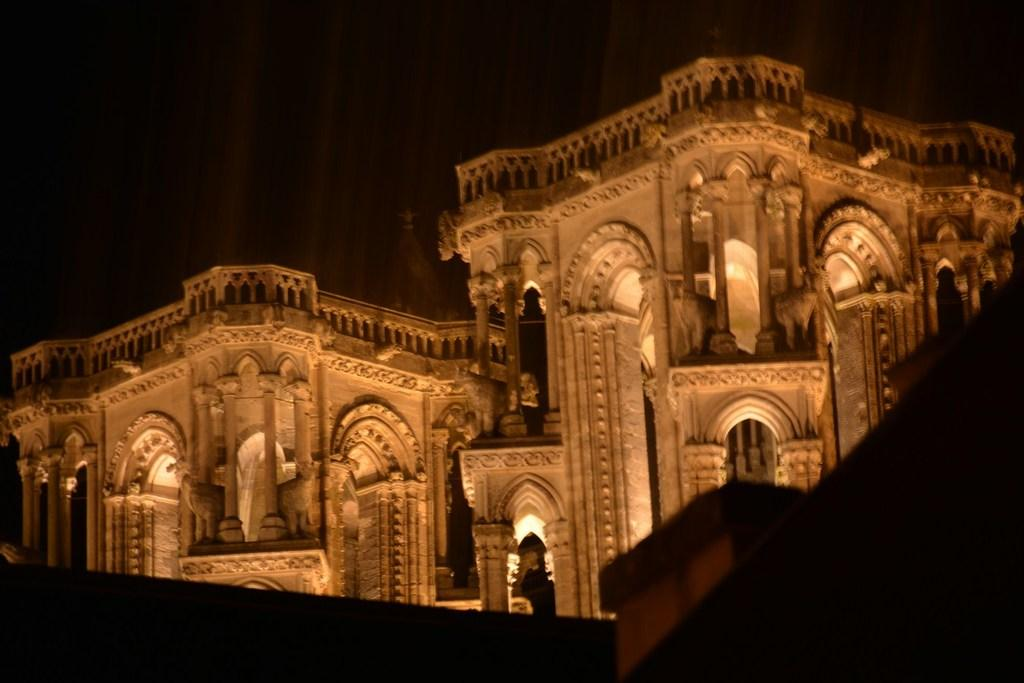What is the main subject of the image? The main subject of the image is a building. What can be seen inside the building? There are lights visible in the building. What is the color of the background in the image? The background of the image is dark. Can you tell me how many crows are sitting on the roof of the building in the image? There is no crow present on the roof of the building in the image. What type of roll is being used to illuminate the building in the image? There is no roll present in the image; the lights visible in the building are likely electric lights. 